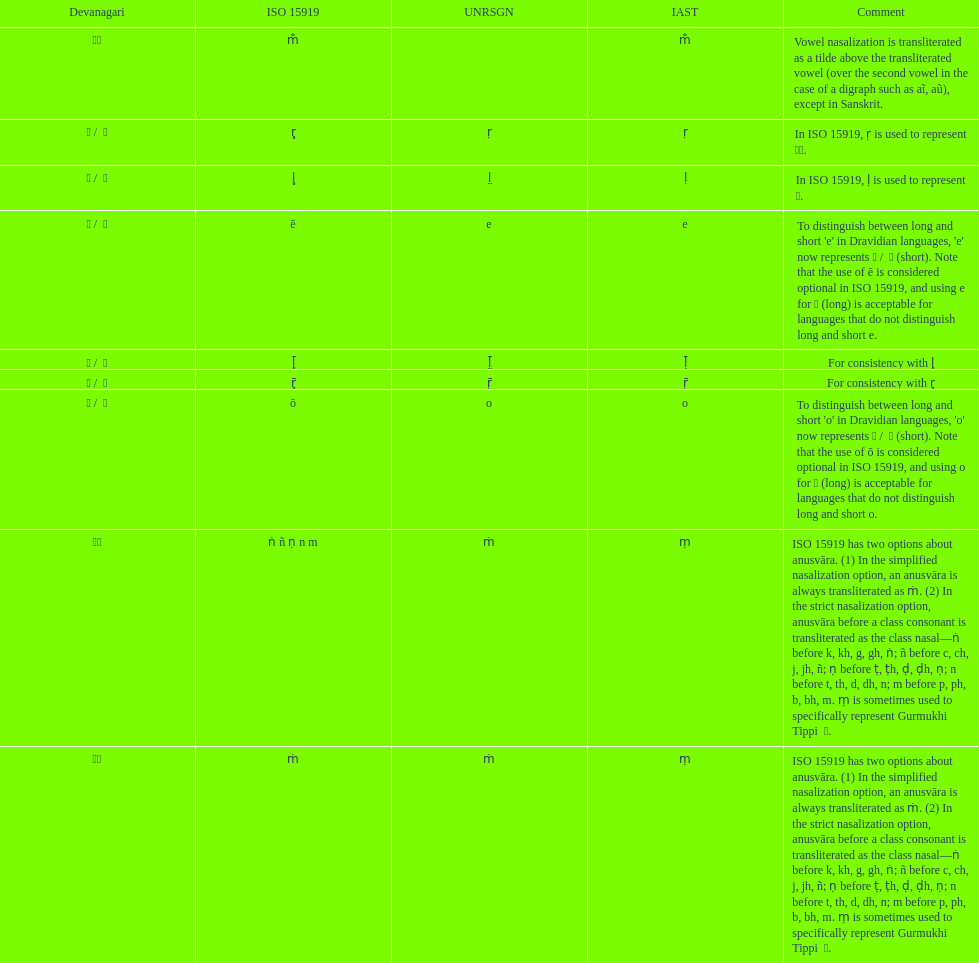What is the total number of alternatives related to anusvara? 2. 